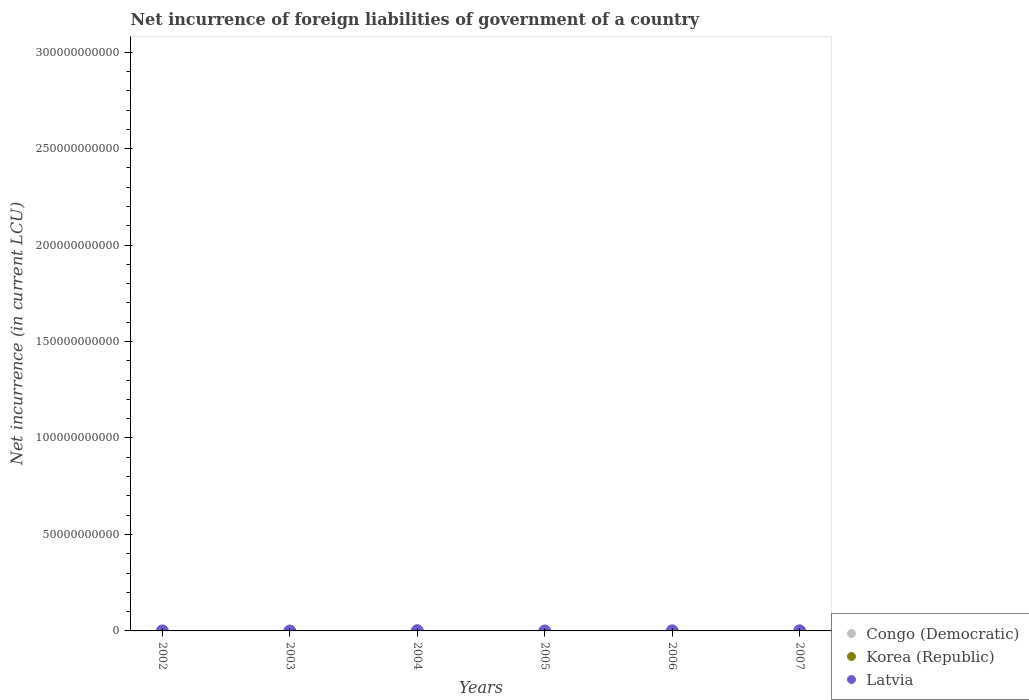How many different coloured dotlines are there?
Offer a terse response. 1. Is the number of dotlines equal to the number of legend labels?
Offer a terse response. No. Across all years, what is the maximum net incurrence of foreign liabilities in Latvia?
Offer a terse response. 1.27e+08. Across all years, what is the minimum net incurrence of foreign liabilities in Congo (Democratic)?
Your answer should be very brief. 0. In which year was the net incurrence of foreign liabilities in Latvia maximum?
Your answer should be compact. 2004. What is the total net incurrence of foreign liabilities in Congo (Democratic) in the graph?
Your answer should be compact. 0. What is the difference between the net incurrence of foreign liabilities in Latvia in 2006 and that in 2007?
Keep it short and to the point. -1.64e+07. What is the difference between the net incurrence of foreign liabilities in Latvia in 2006 and the net incurrence of foreign liabilities in Congo (Democratic) in 2007?
Provide a succinct answer. 4.01e+07. What is the average net incurrence of foreign liabilities in Latvia per year?
Offer a very short reply. 3.85e+07. In how many years, is the net incurrence of foreign liabilities in Latvia greater than 90000000000 LCU?
Your response must be concise. 0. What is the difference between the highest and the lowest net incurrence of foreign liabilities in Latvia?
Your response must be concise. 1.27e+08. Is the net incurrence of foreign liabilities in Latvia strictly greater than the net incurrence of foreign liabilities in Korea (Republic) over the years?
Keep it short and to the point. Yes. Is the net incurrence of foreign liabilities in Korea (Republic) strictly less than the net incurrence of foreign liabilities in Latvia over the years?
Your answer should be very brief. Yes. What is the difference between two consecutive major ticks on the Y-axis?
Offer a very short reply. 5.00e+1. Are the values on the major ticks of Y-axis written in scientific E-notation?
Your answer should be compact. No. Does the graph contain any zero values?
Offer a very short reply. Yes. Where does the legend appear in the graph?
Keep it short and to the point. Bottom right. How many legend labels are there?
Your answer should be compact. 3. How are the legend labels stacked?
Your answer should be very brief. Vertical. What is the title of the graph?
Make the answer very short. Net incurrence of foreign liabilities of government of a country. Does "Central African Republic" appear as one of the legend labels in the graph?
Make the answer very short. No. What is the label or title of the Y-axis?
Ensure brevity in your answer.  Net incurrence (in current LCU). What is the Net incurrence (in current LCU) in Korea (Republic) in 2002?
Make the answer very short. 0. What is the Net incurrence (in current LCU) in Latvia in 2002?
Provide a succinct answer. 7.60e+06. What is the Net incurrence (in current LCU) in Congo (Democratic) in 2003?
Keep it short and to the point. 0. What is the Net incurrence (in current LCU) of Latvia in 2003?
Your answer should be compact. 0. What is the Net incurrence (in current LCU) of Korea (Republic) in 2004?
Provide a short and direct response. 0. What is the Net incurrence (in current LCU) of Latvia in 2004?
Your answer should be very brief. 1.27e+08. What is the Net incurrence (in current LCU) of Congo (Democratic) in 2005?
Offer a terse response. 0. What is the Net incurrence (in current LCU) of Latvia in 2005?
Ensure brevity in your answer.  0. What is the Net incurrence (in current LCU) of Korea (Republic) in 2006?
Provide a succinct answer. 0. What is the Net incurrence (in current LCU) of Latvia in 2006?
Offer a very short reply. 4.01e+07. What is the Net incurrence (in current LCU) in Korea (Republic) in 2007?
Make the answer very short. 0. What is the Net incurrence (in current LCU) of Latvia in 2007?
Ensure brevity in your answer.  5.66e+07. Across all years, what is the maximum Net incurrence (in current LCU) of Latvia?
Keep it short and to the point. 1.27e+08. Across all years, what is the minimum Net incurrence (in current LCU) of Latvia?
Keep it short and to the point. 0. What is the total Net incurrence (in current LCU) in Congo (Democratic) in the graph?
Provide a succinct answer. 0. What is the total Net incurrence (in current LCU) in Korea (Republic) in the graph?
Provide a succinct answer. 0. What is the total Net incurrence (in current LCU) of Latvia in the graph?
Ensure brevity in your answer.  2.31e+08. What is the difference between the Net incurrence (in current LCU) of Latvia in 2002 and that in 2004?
Keep it short and to the point. -1.19e+08. What is the difference between the Net incurrence (in current LCU) in Latvia in 2002 and that in 2006?
Make the answer very short. -3.25e+07. What is the difference between the Net incurrence (in current LCU) in Latvia in 2002 and that in 2007?
Keep it short and to the point. -4.90e+07. What is the difference between the Net incurrence (in current LCU) of Latvia in 2004 and that in 2006?
Your answer should be very brief. 8.65e+07. What is the difference between the Net incurrence (in current LCU) of Latvia in 2004 and that in 2007?
Offer a terse response. 7.00e+07. What is the difference between the Net incurrence (in current LCU) in Latvia in 2006 and that in 2007?
Make the answer very short. -1.64e+07. What is the average Net incurrence (in current LCU) in Congo (Democratic) per year?
Keep it short and to the point. 0. What is the average Net incurrence (in current LCU) in Latvia per year?
Provide a short and direct response. 3.85e+07. What is the ratio of the Net incurrence (in current LCU) of Latvia in 2002 to that in 2004?
Give a very brief answer. 0.06. What is the ratio of the Net incurrence (in current LCU) of Latvia in 2002 to that in 2006?
Ensure brevity in your answer.  0.19. What is the ratio of the Net incurrence (in current LCU) of Latvia in 2002 to that in 2007?
Provide a succinct answer. 0.13. What is the ratio of the Net incurrence (in current LCU) of Latvia in 2004 to that in 2006?
Keep it short and to the point. 3.16. What is the ratio of the Net incurrence (in current LCU) in Latvia in 2004 to that in 2007?
Provide a succinct answer. 2.24. What is the ratio of the Net incurrence (in current LCU) of Latvia in 2006 to that in 2007?
Your answer should be compact. 0.71. What is the difference between the highest and the second highest Net incurrence (in current LCU) in Latvia?
Give a very brief answer. 7.00e+07. What is the difference between the highest and the lowest Net incurrence (in current LCU) of Latvia?
Keep it short and to the point. 1.27e+08. 